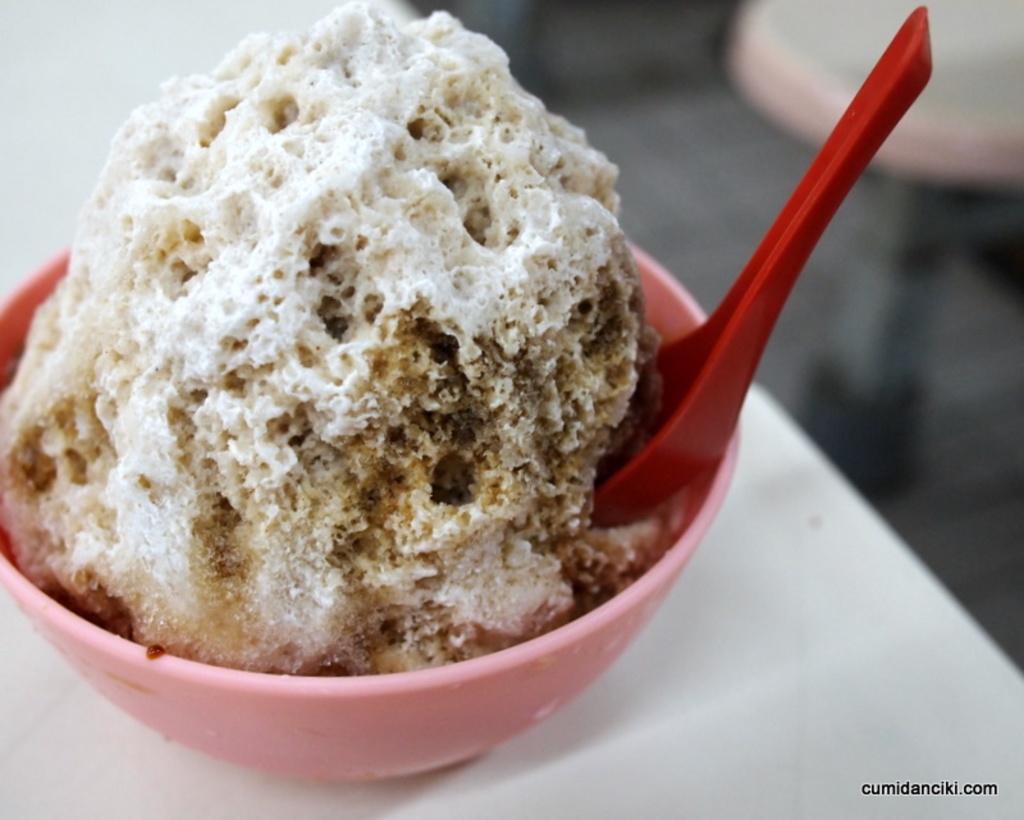Can you describe this image briefly? In this image, There is a table which is in white color on that table there is a bowl which is in pink color and there is a spoon in red color and there is ice cream in white color. 